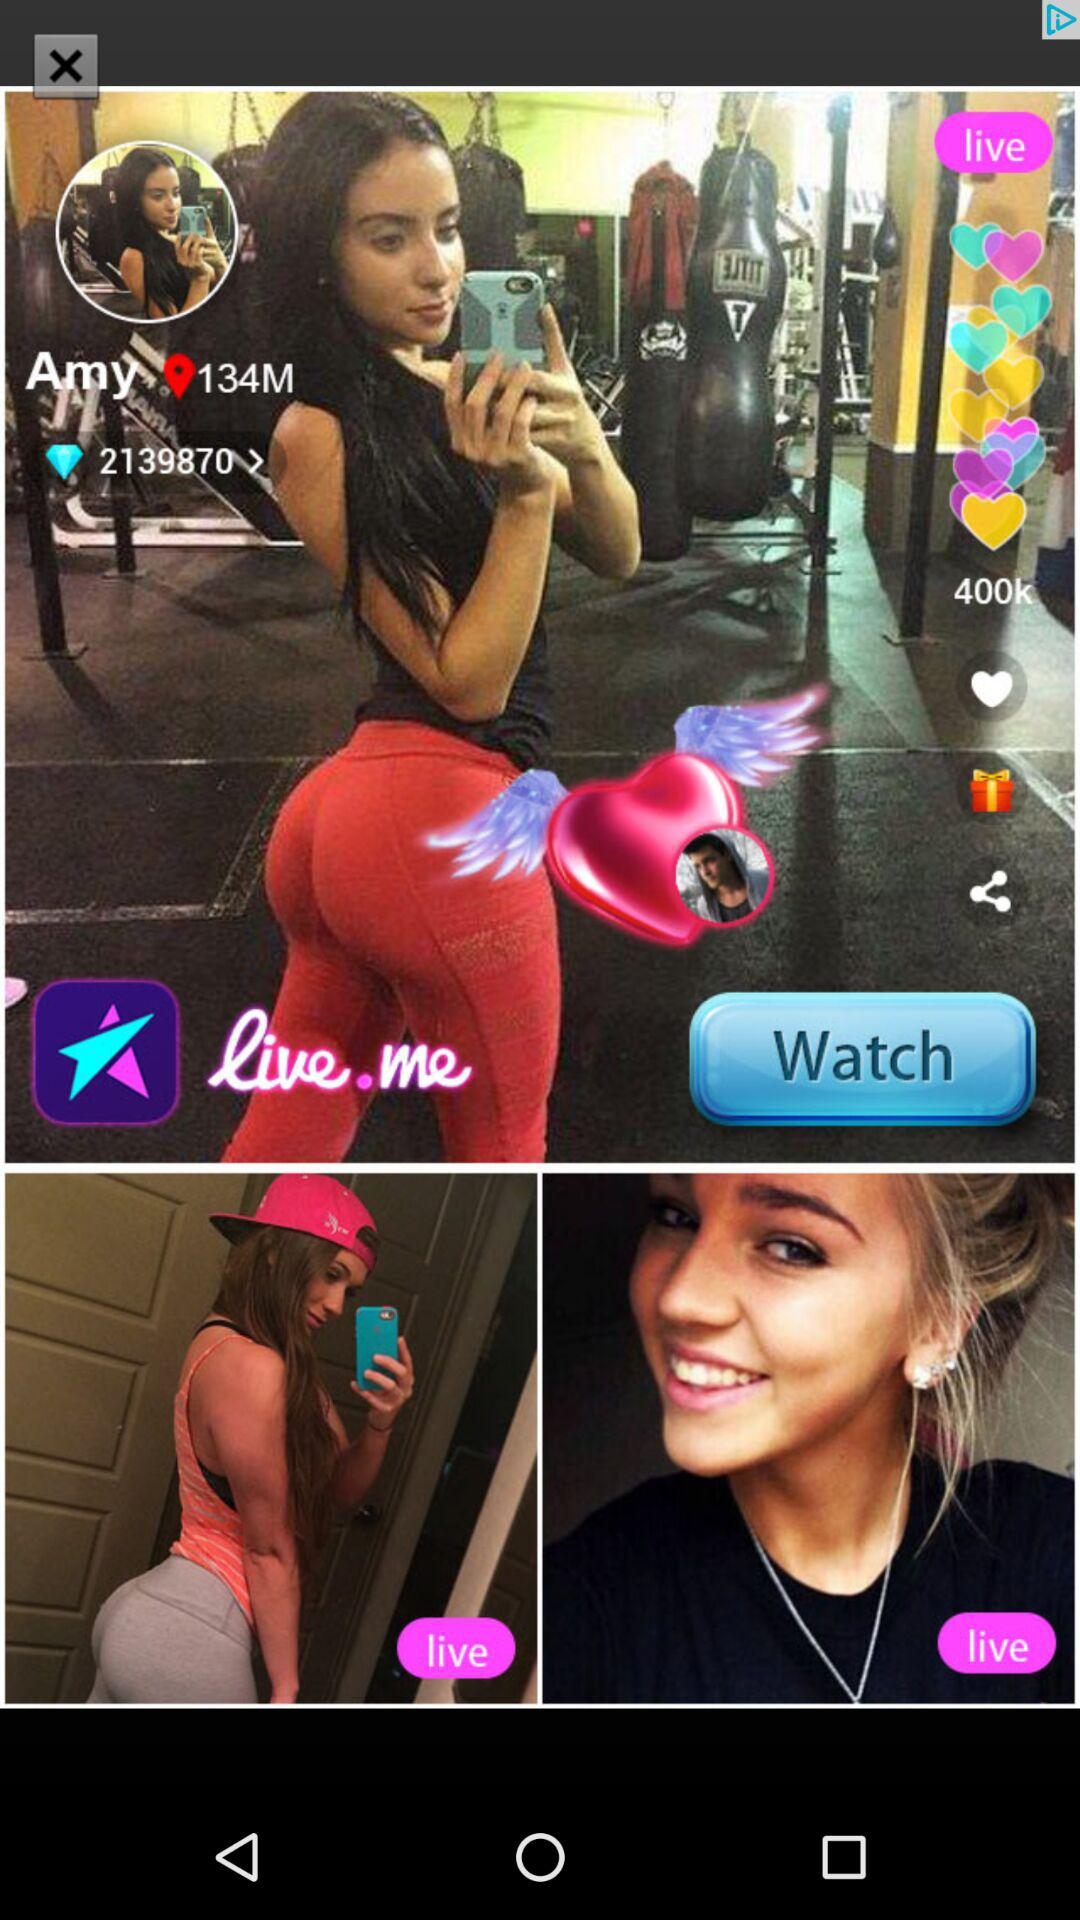How many likes are there of Amy's live stream? There are 400k likes. 